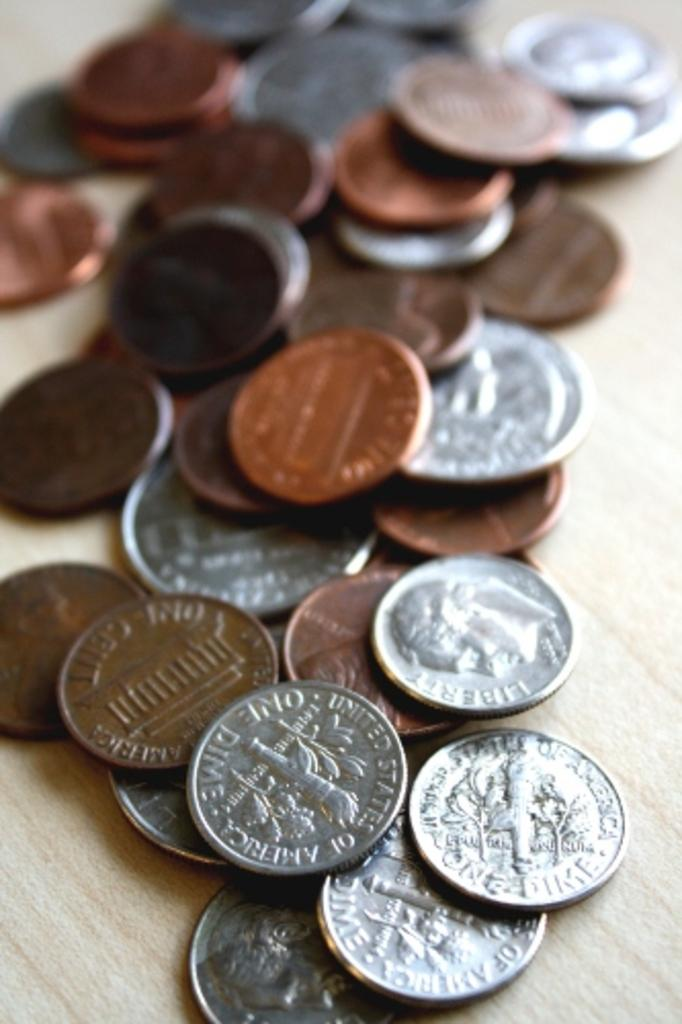<image>
Present a compact description of the photo's key features. A pile of USD coins, including pennies, nickels, dimes, and quarters with "United States of America" on the tails side. 